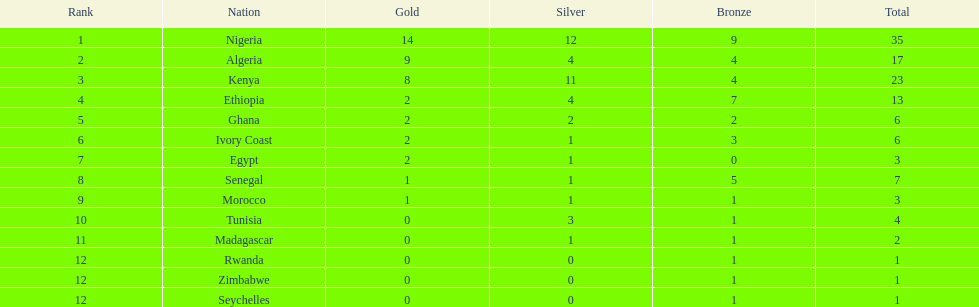Help me parse the entirety of this table. {'header': ['Rank', 'Nation', 'Gold', 'Silver', 'Bronze', 'Total'], 'rows': [['1', 'Nigeria', '14', '12', '9', '35'], ['2', 'Algeria', '9', '4', '4', '17'], ['3', 'Kenya', '8', '11', '4', '23'], ['4', 'Ethiopia', '2', '4', '7', '13'], ['5', 'Ghana', '2', '2', '2', '6'], ['6', 'Ivory Coast', '2', '1', '3', '6'], ['7', 'Egypt', '2', '1', '0', '3'], ['8', 'Senegal', '1', '1', '5', '7'], ['9', 'Morocco', '1', '1', '1', '3'], ['10', 'Tunisia', '0', '3', '1', '4'], ['11', 'Madagascar', '0', '1', '1', '2'], ['12', 'Rwanda', '0', '0', '1', '1'], ['12', 'Zimbabwe', '0', '0', '1', '1'], ['12', 'Seychelles', '0', '0', '1', '1']]} Which nations have won only one medal? Rwanda, Zimbabwe, Seychelles. 